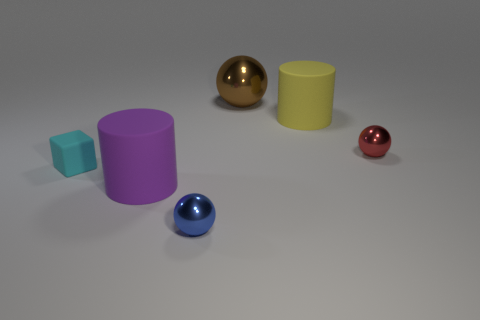What is the size of the red metallic object?
Give a very brief answer. Small. There is a rubber cylinder that is on the left side of the tiny ball to the left of the tiny shiny thing that is behind the cyan thing; what size is it?
Your response must be concise. Large. Is there a red sphere made of the same material as the large purple thing?
Ensure brevity in your answer.  No. The tiny cyan rubber thing is what shape?
Make the answer very short. Cube. There is a cylinder that is the same material as the big purple thing; what color is it?
Provide a succinct answer. Yellow. What number of cyan things are blocks or small objects?
Provide a short and direct response. 1. Are there more big yellow rubber cylinders than tiny gray cylinders?
Offer a very short reply. Yes. What number of objects are objects that are in front of the tiny matte thing or big purple things that are in front of the yellow cylinder?
Offer a very short reply. 2. What color is the other shiny object that is the same size as the yellow thing?
Your answer should be very brief. Brown. Do the large yellow cylinder and the large purple cylinder have the same material?
Your answer should be very brief. Yes. 